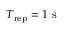Convert formula to latex. <formula><loc_0><loc_0><loc_500><loc_500>T _ { r e p } = 1 s</formula> 